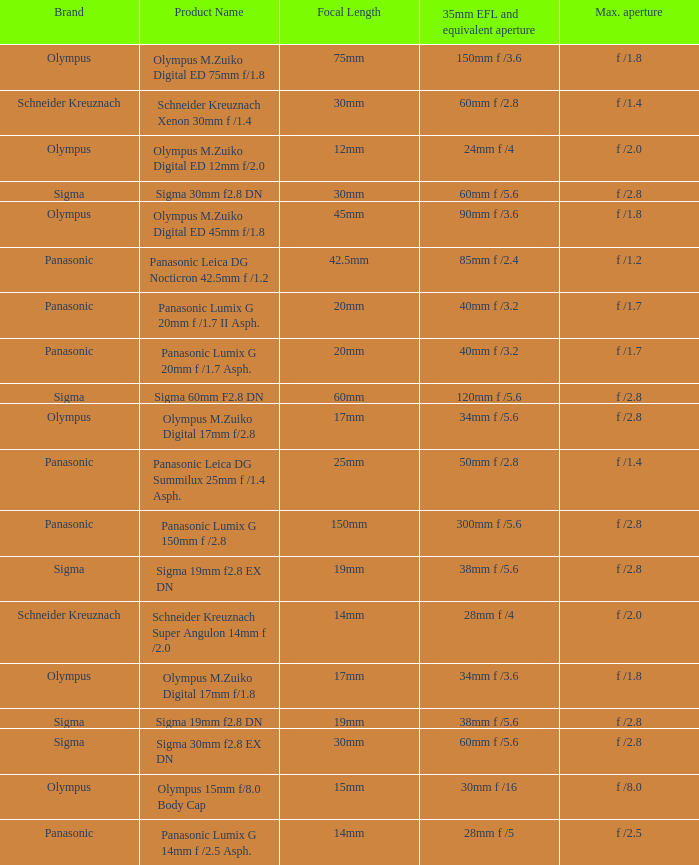What is the brand of the Sigma 30mm f2.8 DN, which has a maximum aperture of f /2.8 and a focal length of 30mm? Sigma. 